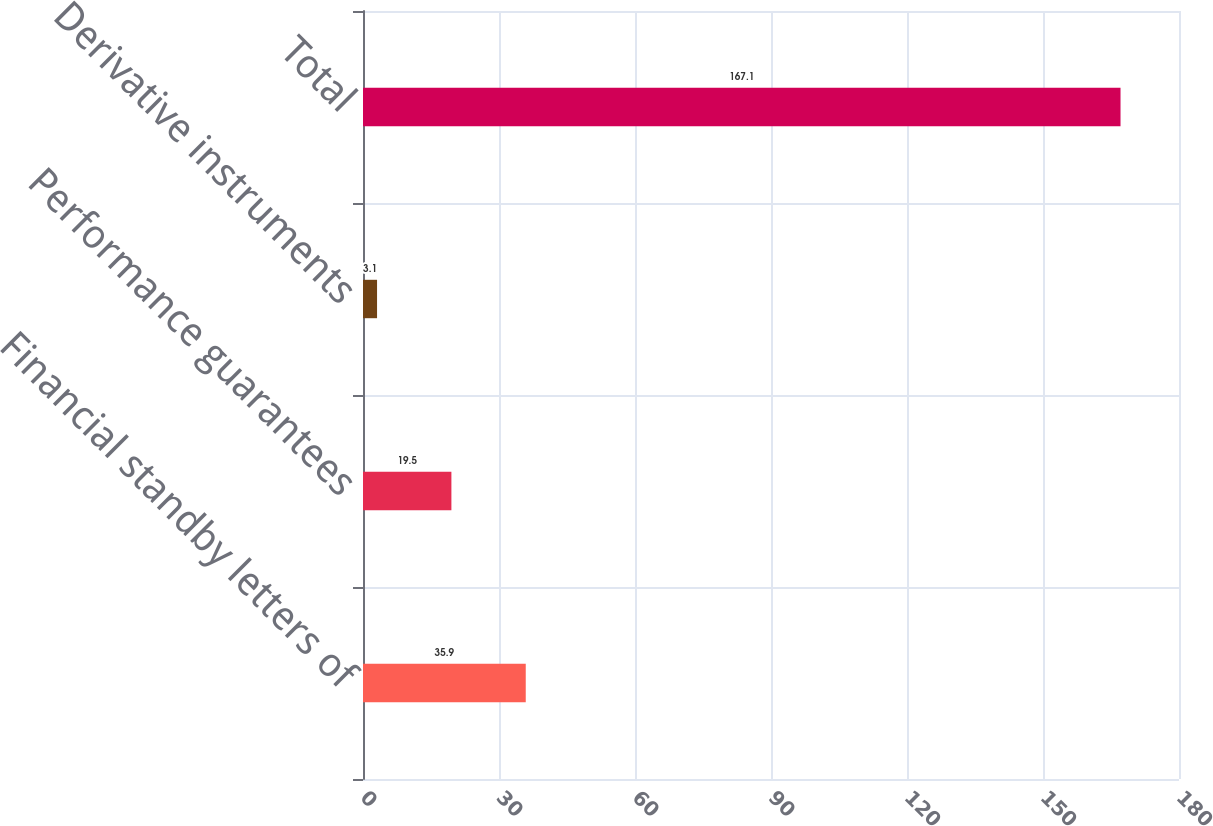<chart> <loc_0><loc_0><loc_500><loc_500><bar_chart><fcel>Financial standby letters of<fcel>Performance guarantees<fcel>Derivative instruments<fcel>Total<nl><fcel>35.9<fcel>19.5<fcel>3.1<fcel>167.1<nl></chart> 